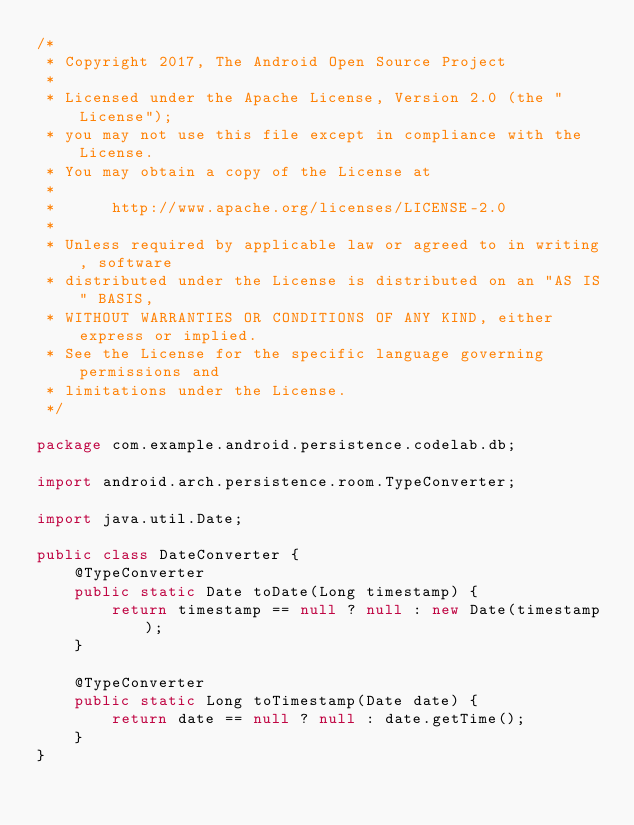<code> <loc_0><loc_0><loc_500><loc_500><_Java_>/*
 * Copyright 2017, The Android Open Source Project
 *
 * Licensed under the Apache License, Version 2.0 (the "License");
 * you may not use this file except in compliance with the License.
 * You may obtain a copy of the License at
 *
 *      http://www.apache.org/licenses/LICENSE-2.0
 *
 * Unless required by applicable law or agreed to in writing, software
 * distributed under the License is distributed on an "AS IS" BASIS,
 * WITHOUT WARRANTIES OR CONDITIONS OF ANY KIND, either express or implied.
 * See the License for the specific language governing permissions and
 * limitations under the License.
 */

package com.example.android.persistence.codelab.db;

import android.arch.persistence.room.TypeConverter;

import java.util.Date;

public class DateConverter {
    @TypeConverter
    public static Date toDate(Long timestamp) {
        return timestamp == null ? null : new Date(timestamp);
    }

    @TypeConverter
    public static Long toTimestamp(Date date) {
        return date == null ? null : date.getTime();
    }
}
</code> 